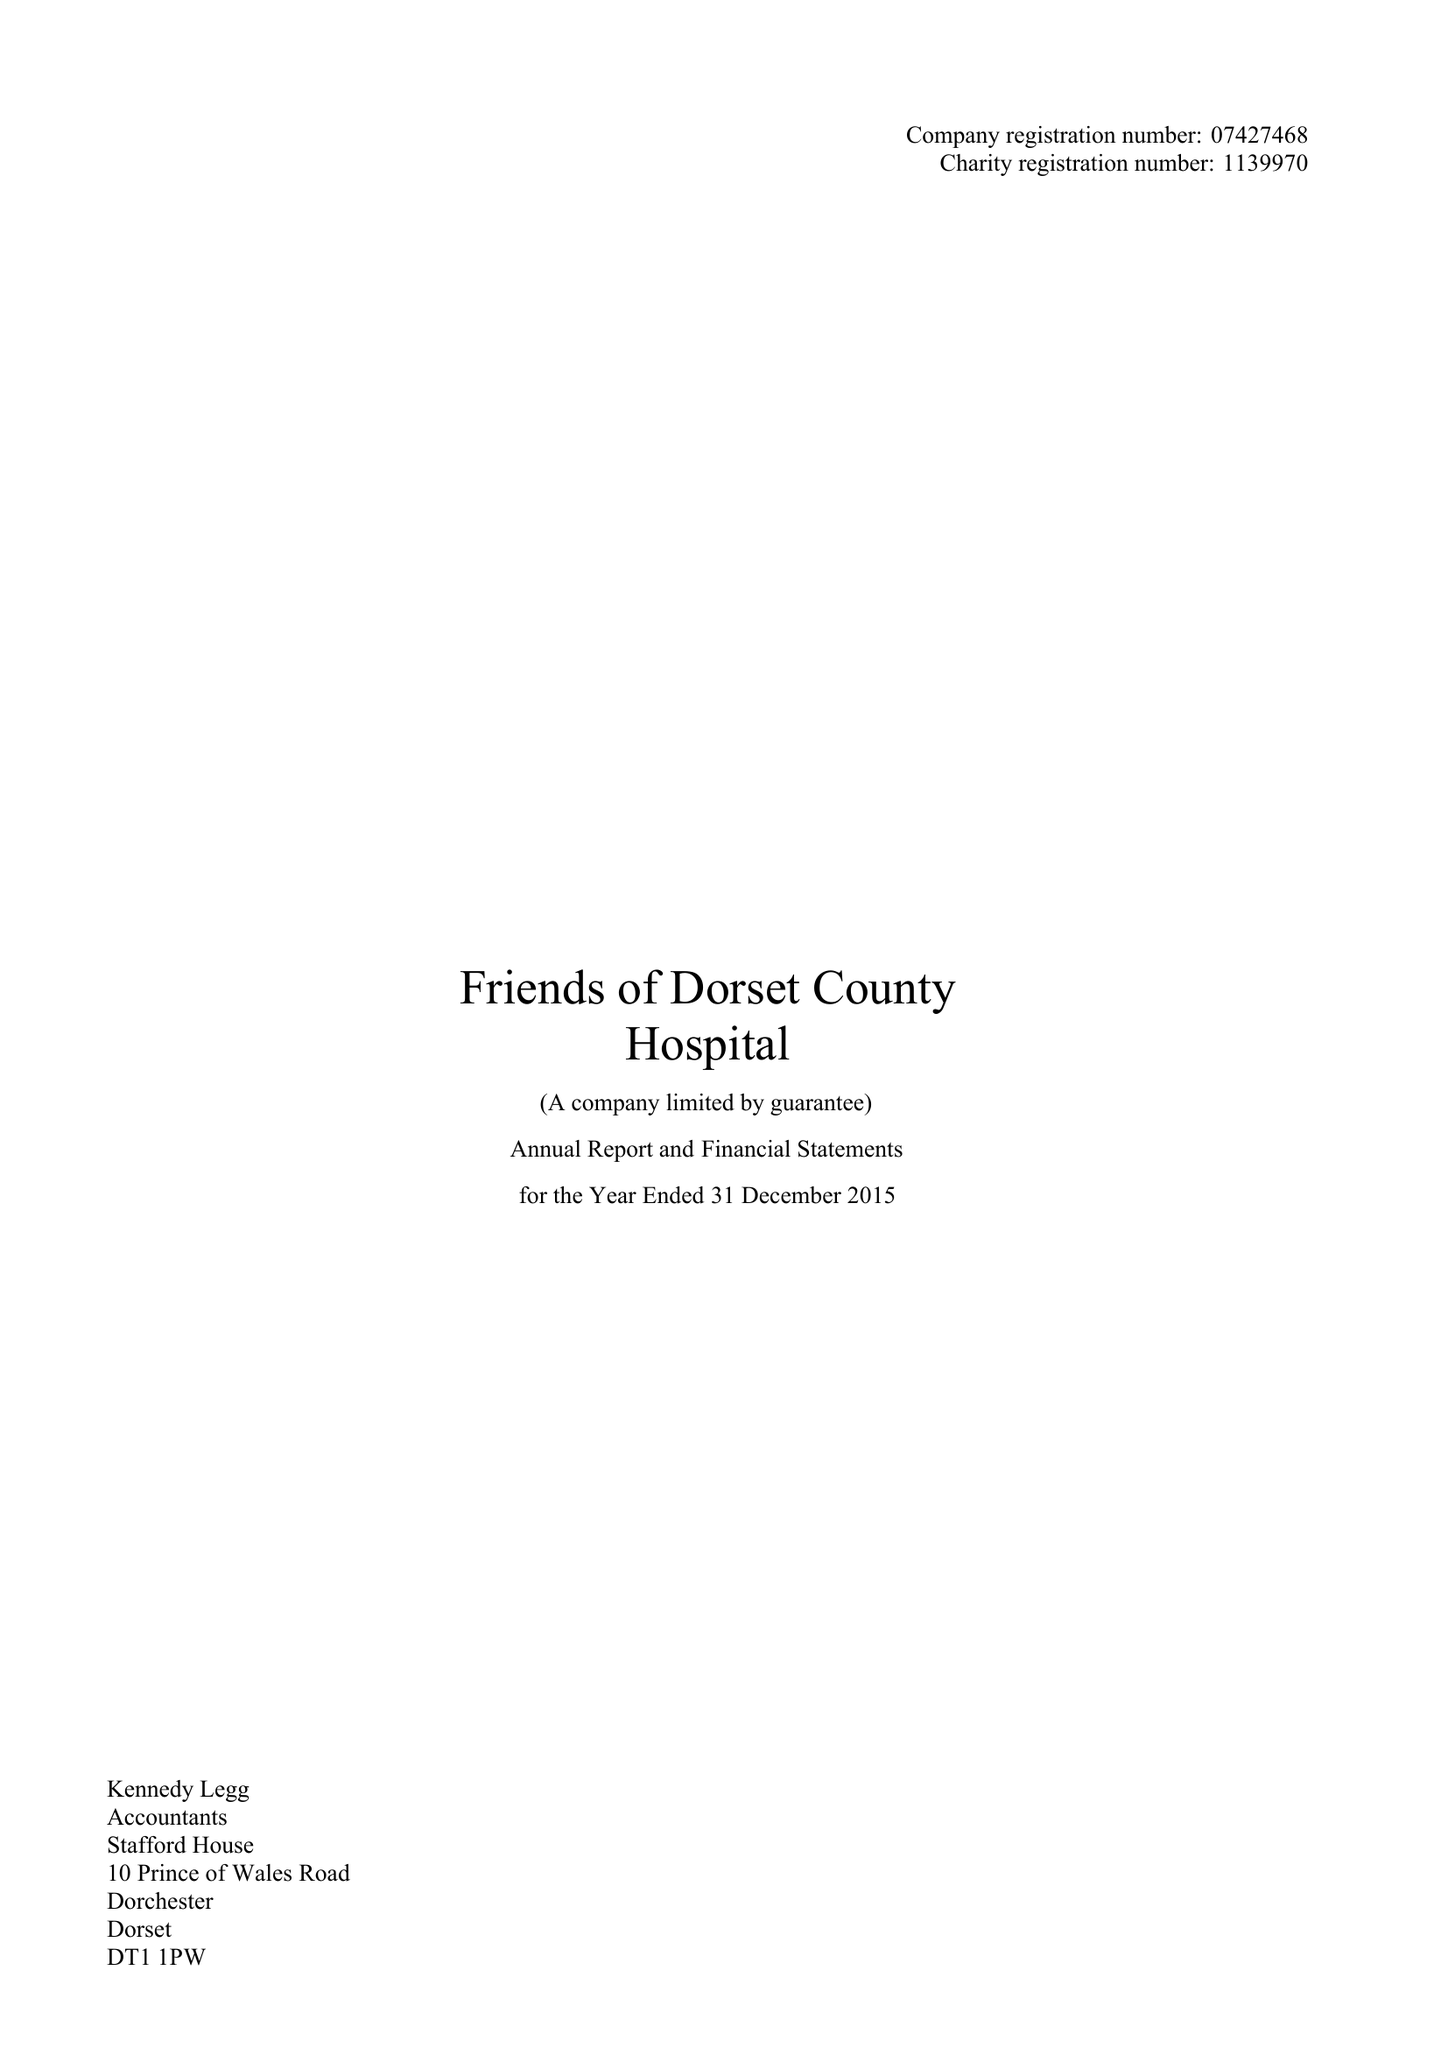What is the value for the address__postcode?
Answer the question using a single word or phrase. DT1 1PW 